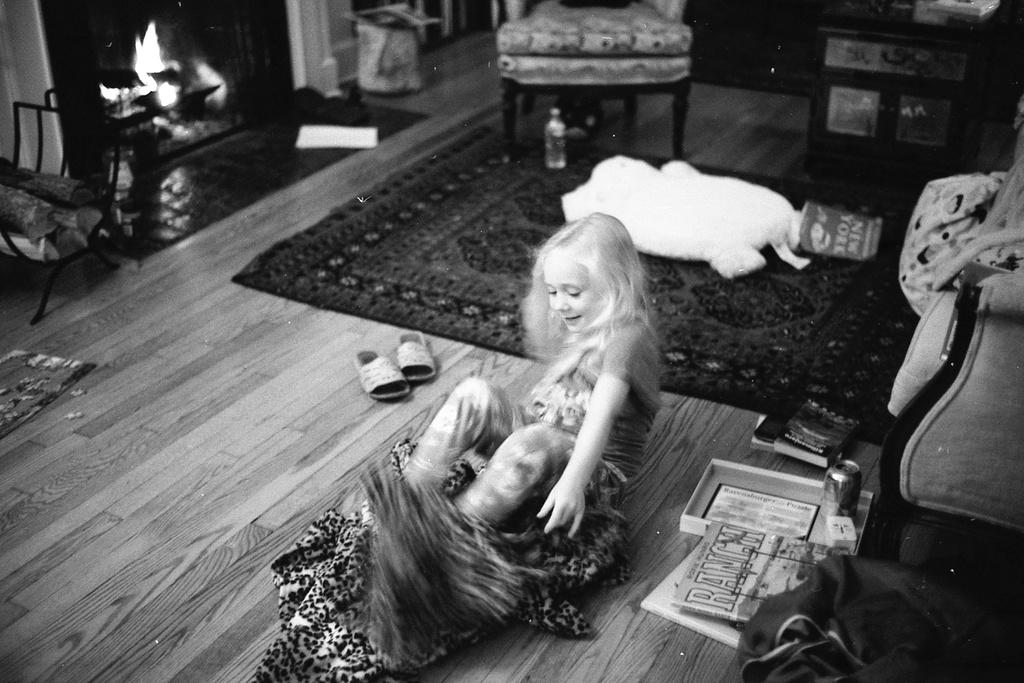Who is present in the picture? There is a girl in the picture. What items related to learning or reading can be seen in the picture? There are books, paper, and a box in the picture. What type of footwear is visible in the picture? There are sandals in the picture. What container is present in the picture? There is a tin in the picture. What type of toy can be seen in the picture? There is a toy in the picture. What type of flooring is visible in the picture? There is a carpet in the picture. What type of beverage container is present in the picture? There is a bottle in the picture. What type of seating is visible in the picture? There are chairs in the picture. What type of heating element is present in the picture? There is a fireplace in the picture. What invention is being demonstrated by the girl in the picture? There is no invention being demonstrated by the girl in the picture. What type of pest can be seen crawling on the carpet in the picture? There are no pests visible in the picture; it is a clean and tidy room. 